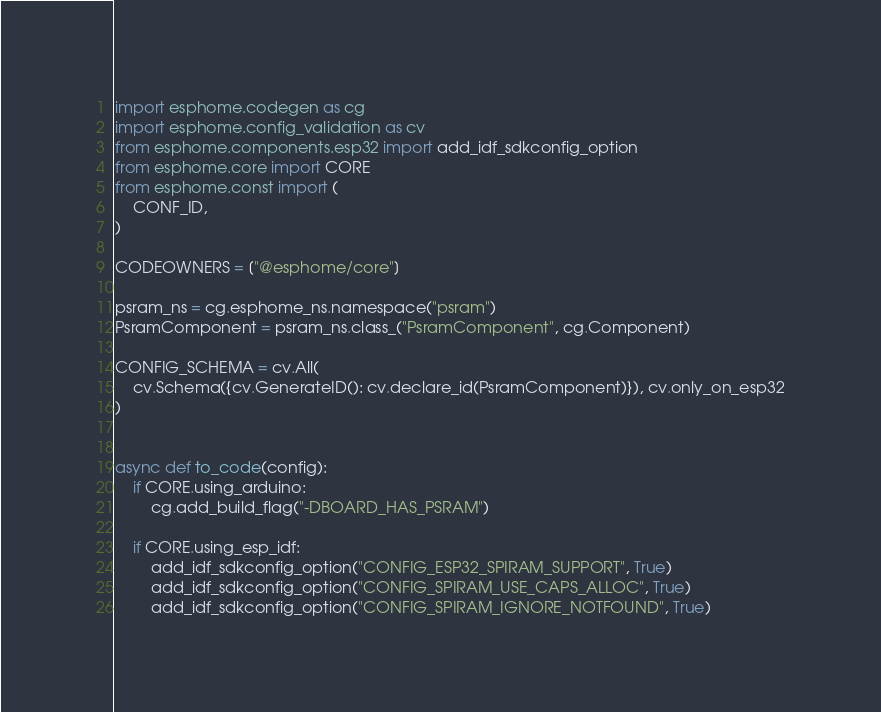<code> <loc_0><loc_0><loc_500><loc_500><_Python_>import esphome.codegen as cg
import esphome.config_validation as cv
from esphome.components.esp32 import add_idf_sdkconfig_option
from esphome.core import CORE
from esphome.const import (
    CONF_ID,
)

CODEOWNERS = ["@esphome/core"]

psram_ns = cg.esphome_ns.namespace("psram")
PsramComponent = psram_ns.class_("PsramComponent", cg.Component)

CONFIG_SCHEMA = cv.All(
    cv.Schema({cv.GenerateID(): cv.declare_id(PsramComponent)}), cv.only_on_esp32
)


async def to_code(config):
    if CORE.using_arduino:
        cg.add_build_flag("-DBOARD_HAS_PSRAM")

    if CORE.using_esp_idf:
        add_idf_sdkconfig_option("CONFIG_ESP32_SPIRAM_SUPPORT", True)
        add_idf_sdkconfig_option("CONFIG_SPIRAM_USE_CAPS_ALLOC", True)
        add_idf_sdkconfig_option("CONFIG_SPIRAM_IGNORE_NOTFOUND", True)
</code> 